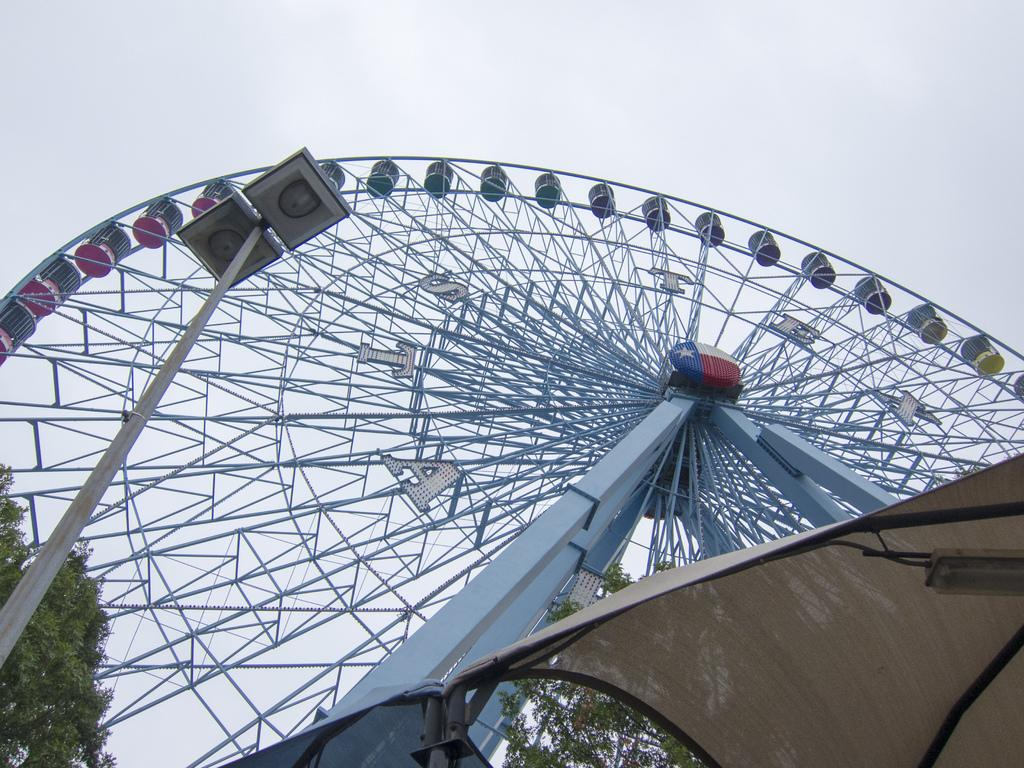What is the main feature in the picture? There is a giant wheel in the picture. What type of natural elements can be seen in the picture? There are trees in the picture. What other objects are present in the picture? There are poles in the picture. What type of animals can be seen at the zoo in the picture? There is no zoo present in the picture, so it is not possible to determine what animals might be seen. 